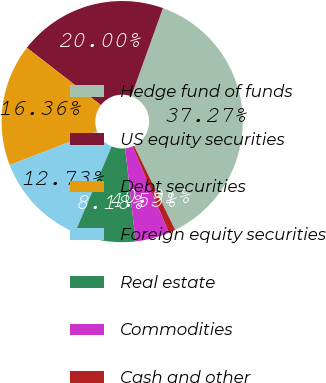<chart> <loc_0><loc_0><loc_500><loc_500><pie_chart><fcel>Hedge fund of funds<fcel>US equity securities<fcel>Debt securities<fcel>Foreign equity securities<fcel>Real estate<fcel>Commodities<fcel>Cash and other<nl><fcel>37.27%<fcel>20.0%<fcel>16.36%<fcel>12.73%<fcel>8.18%<fcel>4.55%<fcel>0.91%<nl></chart> 